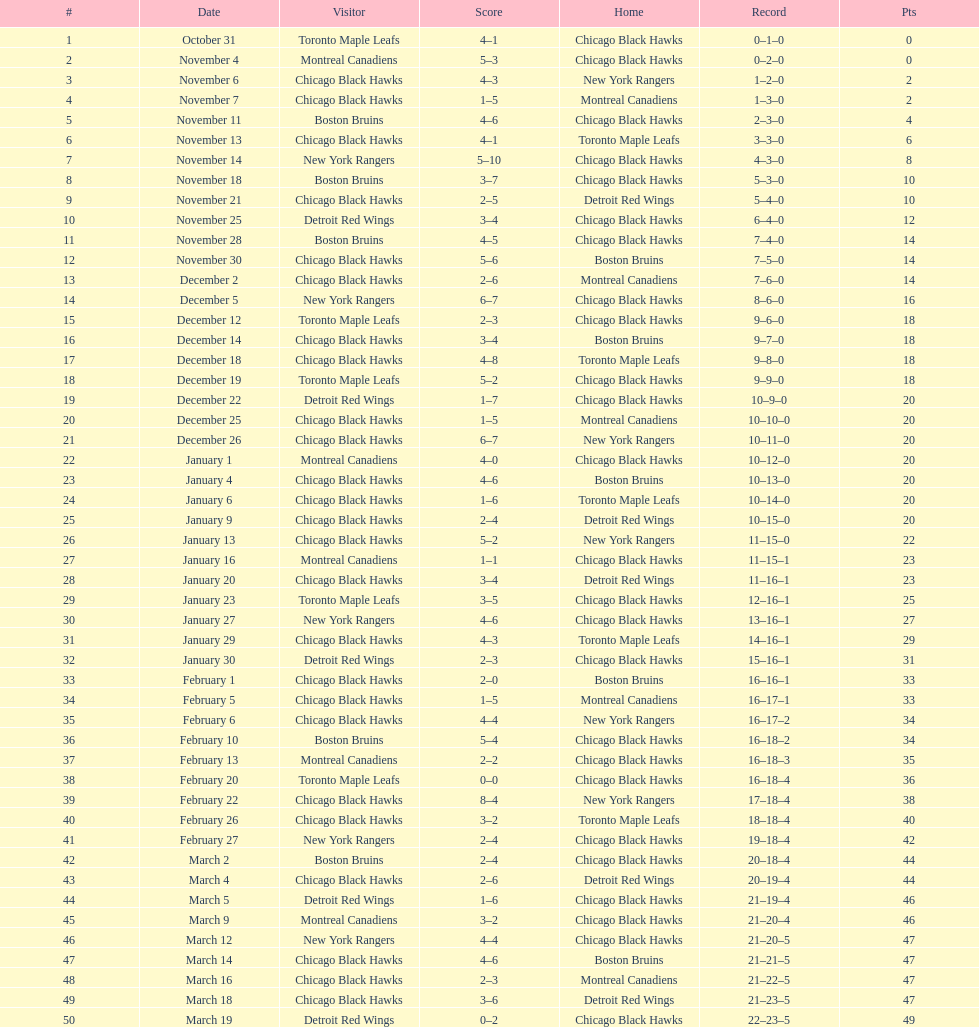Tell me the number of points the blackhawks had on march 4. 44. 